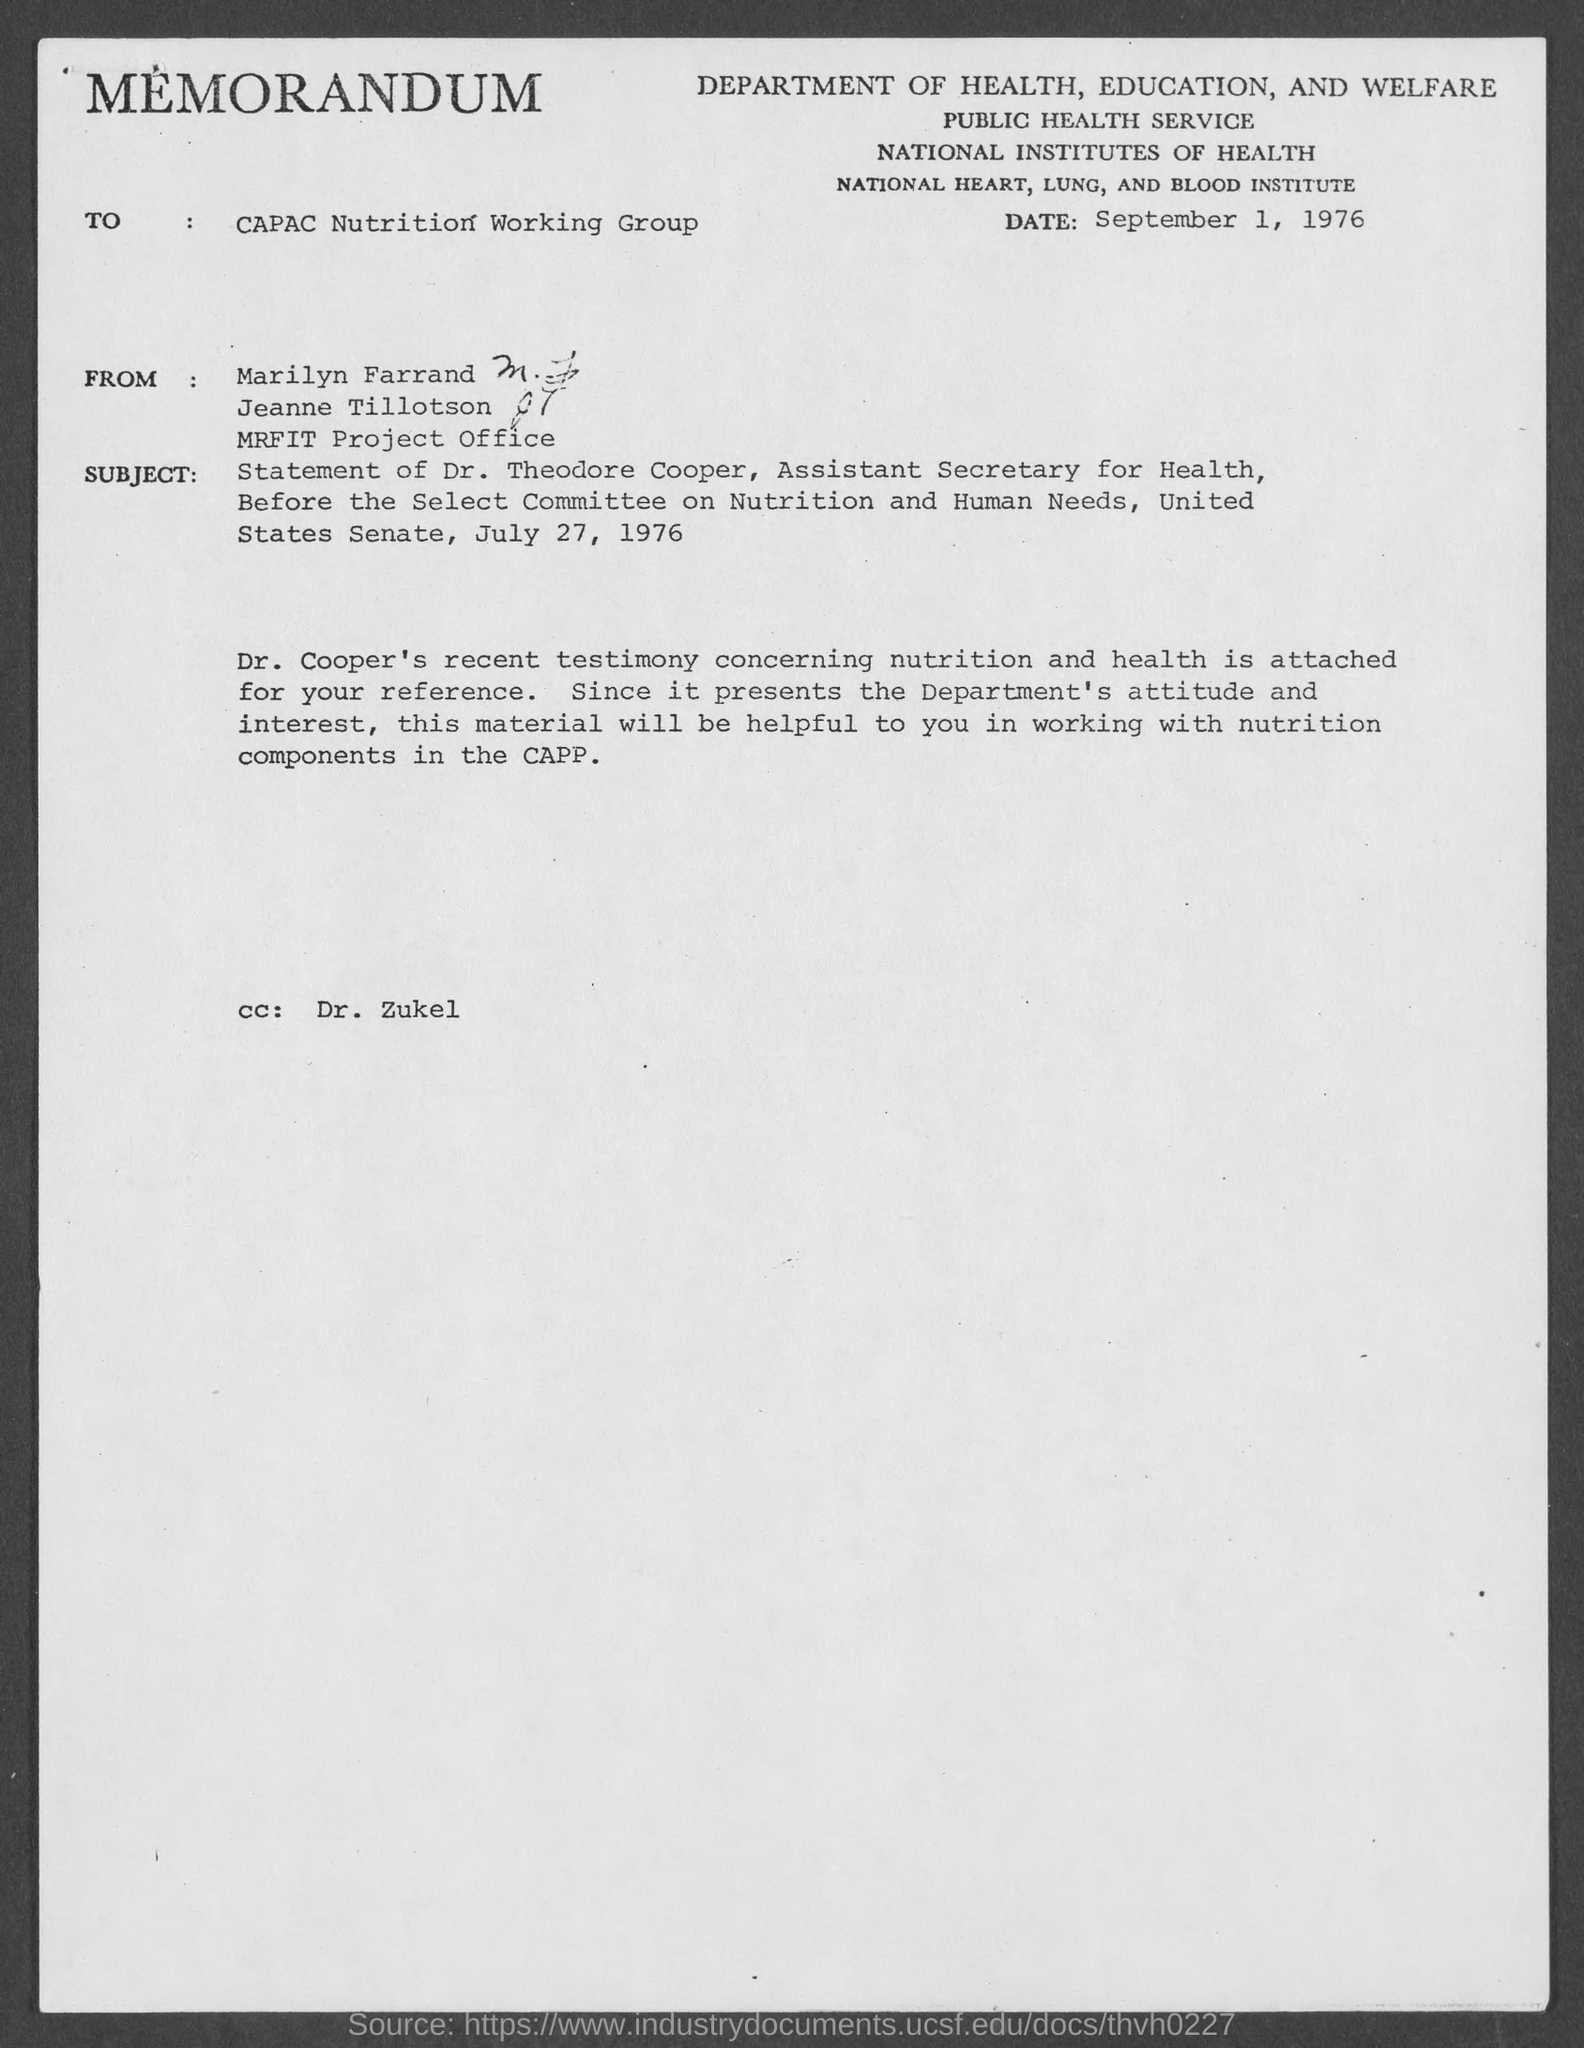What kind of communication is this?
Keep it short and to the point. MEMORANDUM. To whom, the memorandum is addressed?
Offer a terse response. CAPAC Nutrition Working Group. Who is marked in the cc of this memorandum?
Make the answer very short. DR. ZUKEL. 